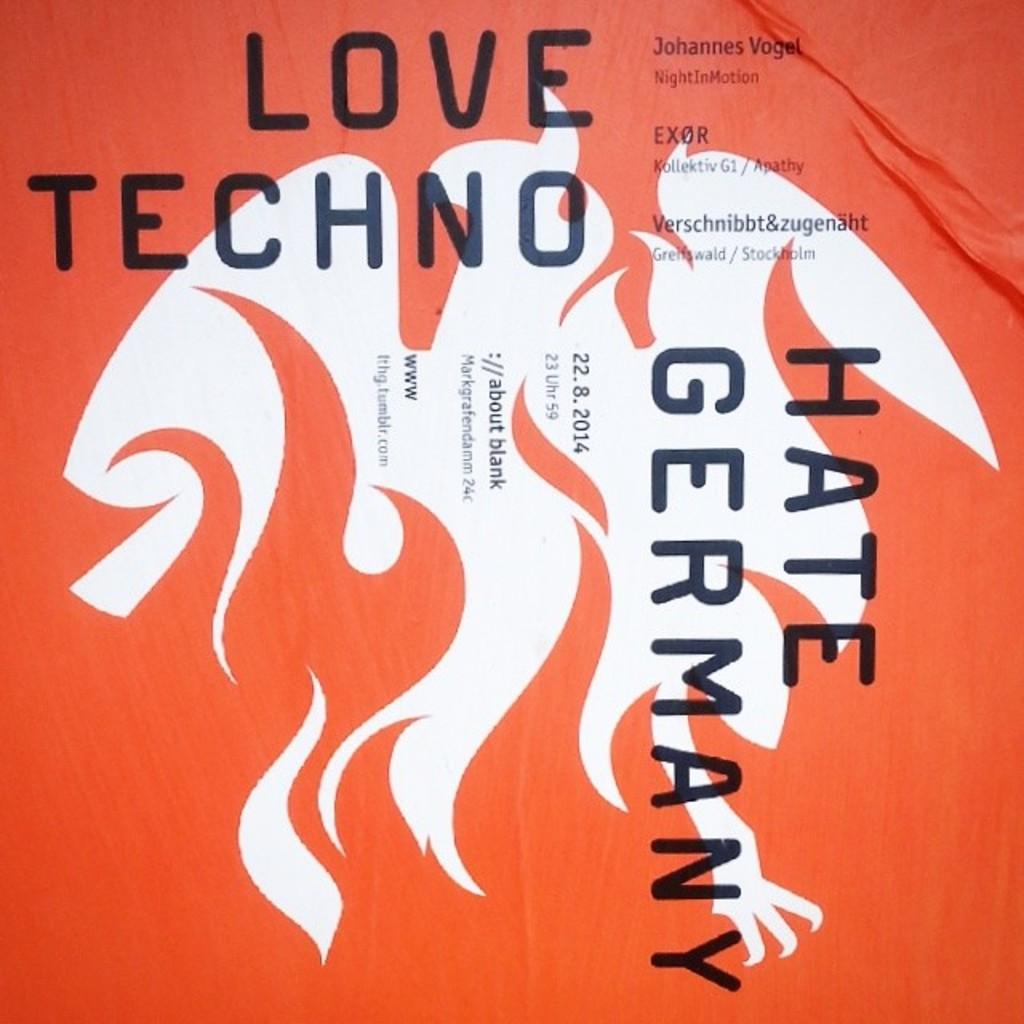<image>
Describe the image concisely. An orange and white album cover for Love Techno. 